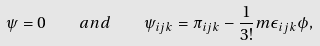<formula> <loc_0><loc_0><loc_500><loc_500>\psi = 0 \quad a n d \quad \psi _ { i j k } = \pi _ { i j k } - \frac { 1 } { 3 ! } m \epsilon _ { i j k } \phi ,</formula> 